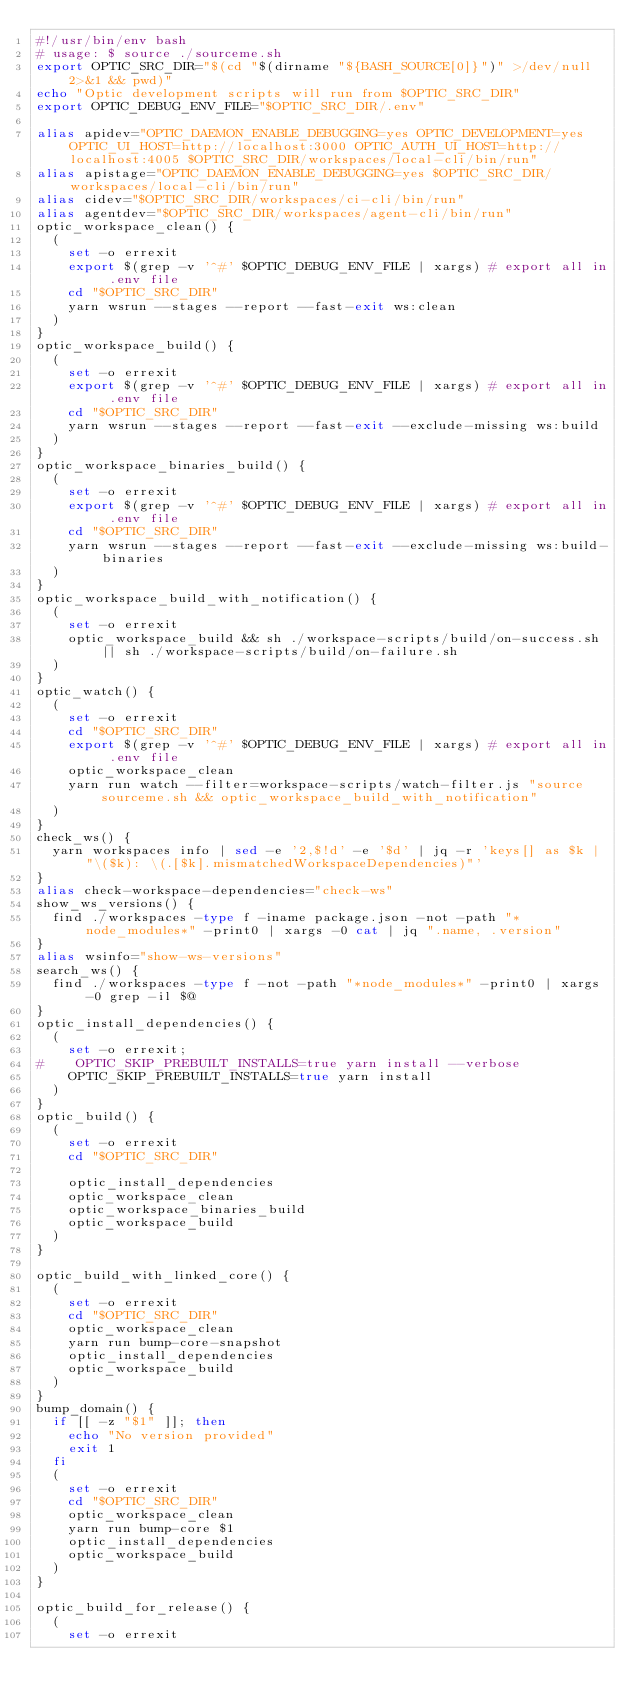<code> <loc_0><loc_0><loc_500><loc_500><_Bash_>#!/usr/bin/env bash
# usage: $ source ./sourceme.sh
export OPTIC_SRC_DIR="$(cd "$(dirname "${BASH_SOURCE[0]}")" >/dev/null 2>&1 && pwd)"
echo "Optic development scripts will run from $OPTIC_SRC_DIR"
export OPTIC_DEBUG_ENV_FILE="$OPTIC_SRC_DIR/.env"

alias apidev="OPTIC_DAEMON_ENABLE_DEBUGGING=yes OPTIC_DEVELOPMENT=yes OPTIC_UI_HOST=http://localhost:3000 OPTIC_AUTH_UI_HOST=http://localhost:4005 $OPTIC_SRC_DIR/workspaces/local-cli/bin/run"
alias apistage="OPTIC_DAEMON_ENABLE_DEBUGGING=yes $OPTIC_SRC_DIR/workspaces/local-cli/bin/run"
alias cidev="$OPTIC_SRC_DIR/workspaces/ci-cli/bin/run"
alias agentdev="$OPTIC_SRC_DIR/workspaces/agent-cli/bin/run"
optic_workspace_clean() {
  (
    set -o errexit
    export $(grep -v '^#' $OPTIC_DEBUG_ENV_FILE | xargs) # export all in .env file
    cd "$OPTIC_SRC_DIR"
    yarn wsrun --stages --report --fast-exit ws:clean
  )
}
optic_workspace_build() {
  (
    set -o errexit
    export $(grep -v '^#' $OPTIC_DEBUG_ENV_FILE | xargs) # export all in .env file
    cd "$OPTIC_SRC_DIR"
    yarn wsrun --stages --report --fast-exit --exclude-missing ws:build
  )
}
optic_workspace_binaries_build() {
  (
    set -o errexit
    export $(grep -v '^#' $OPTIC_DEBUG_ENV_FILE | xargs) # export all in .env file
    cd "$OPTIC_SRC_DIR"
    yarn wsrun --stages --report --fast-exit --exclude-missing ws:build-binaries
  )
}
optic_workspace_build_with_notification() {
  (
    set -o errexit
    optic_workspace_build && sh ./workspace-scripts/build/on-success.sh || sh ./workspace-scripts/build/on-failure.sh
  )
}
optic_watch() {
  (
    set -o errexit
    cd "$OPTIC_SRC_DIR"
    export $(grep -v '^#' $OPTIC_DEBUG_ENV_FILE | xargs) # export all in .env file
    optic_workspace_clean
    yarn run watch --filter=workspace-scripts/watch-filter.js "source sourceme.sh && optic_workspace_build_with_notification"
  )
}
check_ws() {
  yarn workspaces info | sed -e '2,$!d' -e '$d' | jq -r 'keys[] as $k | "\($k): \(.[$k].mismatchedWorkspaceDependencies)"'
}
alias check-workspace-dependencies="check-ws"
show_ws_versions() {
  find ./workspaces -type f -iname package.json -not -path "*node_modules*" -print0 | xargs -0 cat | jq ".name, .version"
}
alias wsinfo="show-ws-versions"
search_ws() {
  find ./workspaces -type f -not -path "*node_modules*" -print0 | xargs -0 grep -il $@
}
optic_install_dependencies() {
  (
    set -o errexit;
#    OPTIC_SKIP_PREBUILT_INSTALLS=true yarn install --verbose
    OPTIC_SKIP_PREBUILT_INSTALLS=true yarn install
  )
}
optic_build() {
  (
    set -o errexit
    cd "$OPTIC_SRC_DIR"

    optic_install_dependencies
    optic_workspace_clean
    optic_workspace_binaries_build
    optic_workspace_build
  )
}

optic_build_with_linked_core() {
  (
    set -o errexit
    cd "$OPTIC_SRC_DIR"
    optic_workspace_clean
    yarn run bump-core-snapshot
    optic_install_dependencies
    optic_workspace_build
  )
}
bump_domain() {
  if [[ -z "$1" ]]; then
    echo "No version provided"
    exit 1
  fi
  (
    set -o errexit
    cd "$OPTIC_SRC_DIR"
    optic_workspace_clean
    yarn run bump-core $1
    optic_install_dependencies
    optic_workspace_build
  )
}

optic_build_for_release() {
  (
    set -o errexit</code> 